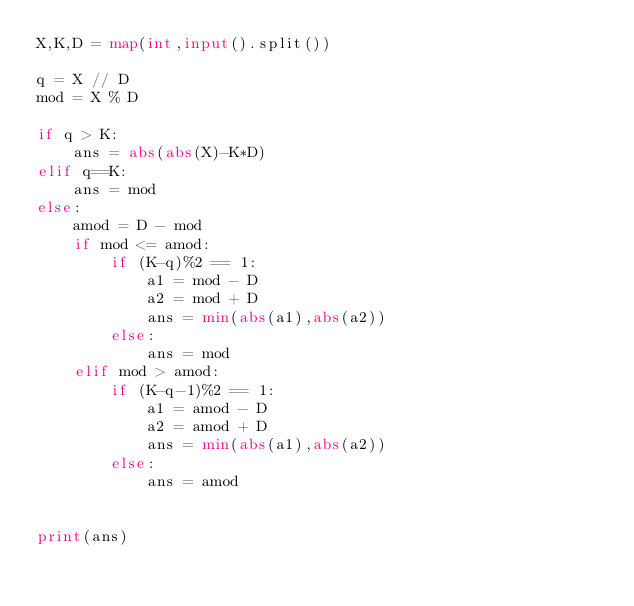Convert code to text. <code><loc_0><loc_0><loc_500><loc_500><_Python_>X,K,D = map(int,input().split())

q = X // D
mod = X % D

if q > K:
    ans = abs(abs(X)-K*D)
elif q==K:
    ans = mod
else:
    amod = D - mod
    if mod <= amod:
        if (K-q)%2 == 1:
            a1 = mod - D
            a2 = mod + D
            ans = min(abs(a1),abs(a2))
        else:
            ans = mod
    elif mod > amod:
        if (K-q-1)%2 == 1:
            a1 = amod - D
            a2 = amod + D
            ans = min(abs(a1),abs(a2))
        else:
            ans = amod


print(ans)</code> 